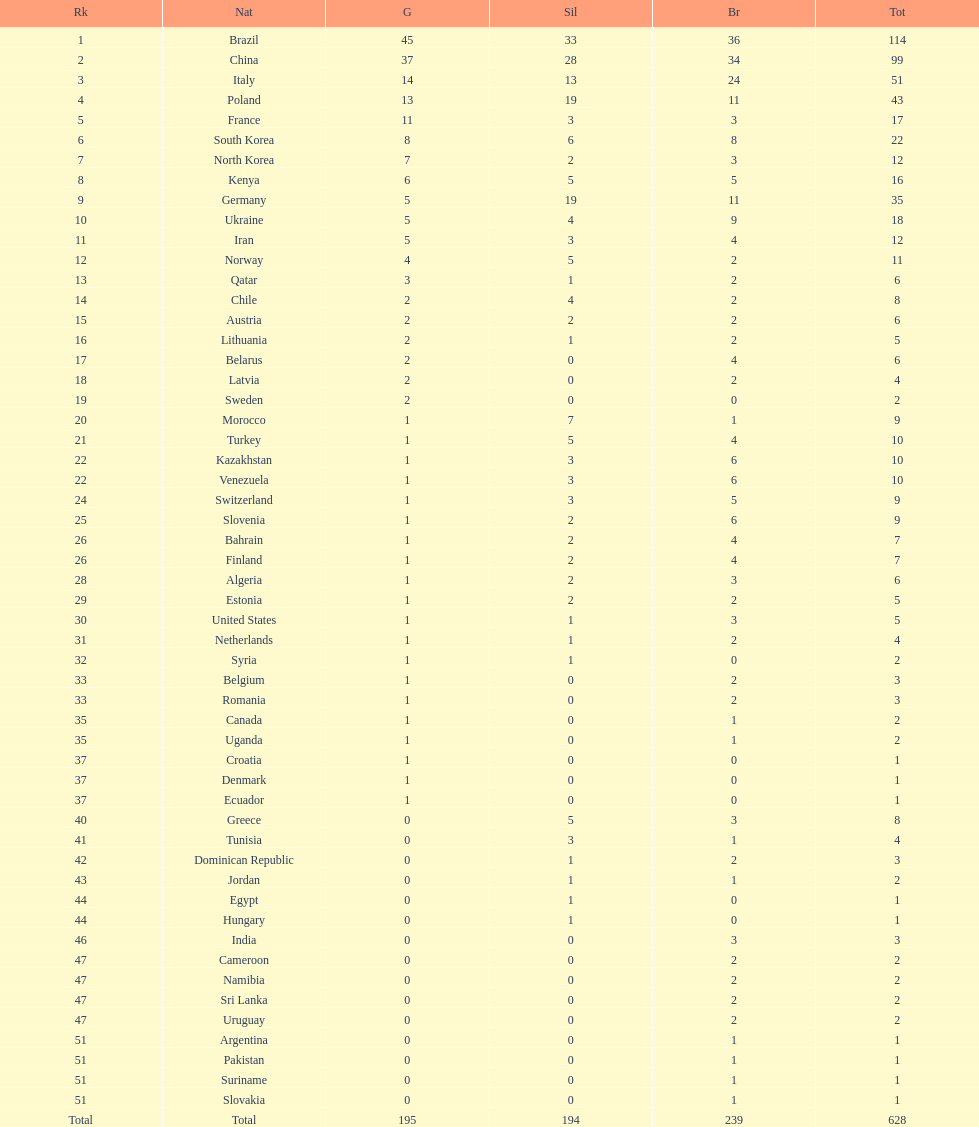What is the cumulative sum of medals between south korea, north korea, sweden, and brazil? 150. 